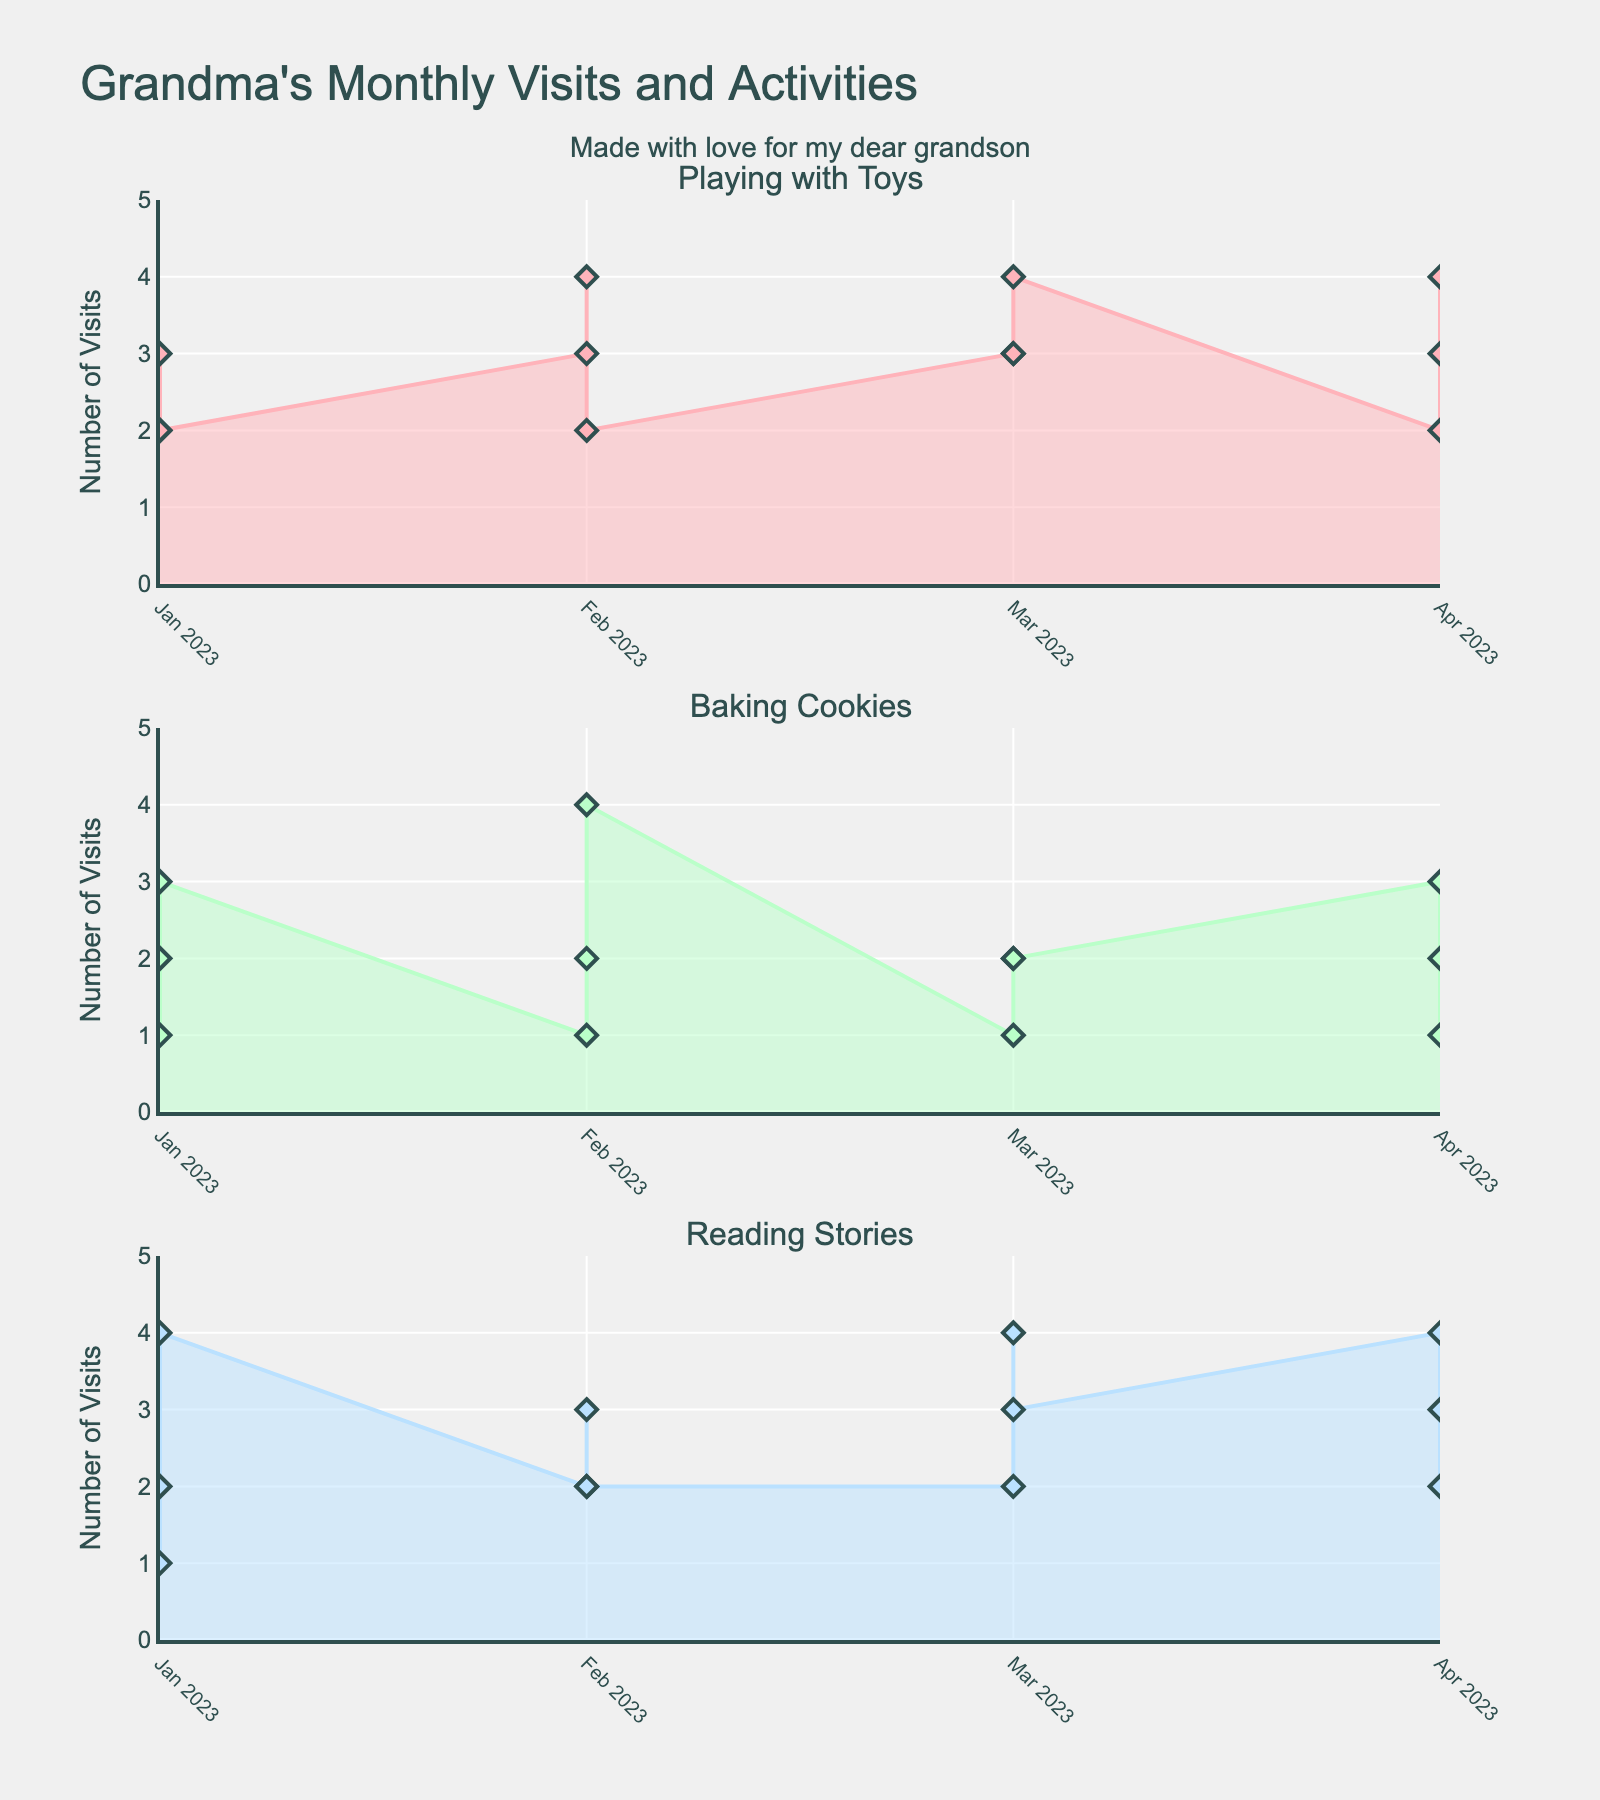How many times did you visit your grandson in March just to bake cookies? In the March subplot for the "Baking Cookies" activity, locate the data point for March. The value shown is 3 visits.
Answer: 3 Which month had the highest number of visits for playing with toys? Scan through each subplot and identify the maximum value on the "Playing with Toys" subplot. April, May, September, and December have the highest value, which is 4 visits.
Answer: April, May, September, and December What was the total number of visits in August? Sum up the visits for each activity in the August subplot (Playing with Toys: 3, Baking Cookies: 2, Reading Stories: 4). So, 3 + 2 + 4 = 9 visits.
Answer: 9 How does the number of visits for reading stories in February compare to January? Compare the data points on the "Reading Stories" subplot for January and February. January has 2 visits, and February has 1 visit. The visits in February are fewer than in January.
Answer: Fewer How many months had more than 3 visits for baking cookies? Identify the months in the "Baking Cookies" subplot where the data point is greater than 3. Only June has 4 visits.
Answer: 1 During which month did you have the most balanced distribution of activities? A balanced distribution means similar numbers of visits across all activities. Identify the month where activities have similar values. January has 2, 1, and 2 for Playing with Toys, Baking Cookies, and Reading Stories respectively, making it the most balanced month.
Answer: January What was the total number of visits to your grandson in the entire year? To find the total annual visits, sum up the values from all three subplots across all months:
(2+1+2) + (3+2+1) + (2+3+4) + (3+1+2) + (4+2+3) + (2+4+2) + (3+1+2) + (3+2+4) + (4+2+3) + (2+3+4) + (3+1+2) + (4+2+3) = 66
Answer: 66 In how many months did you visit your grandson for reading stories more than for baking cookies? Check each month in the two subplots for "Reading Stories" and "Baking Cookies" and compare. The months are March, April, May, August, October.
Answer: 5 